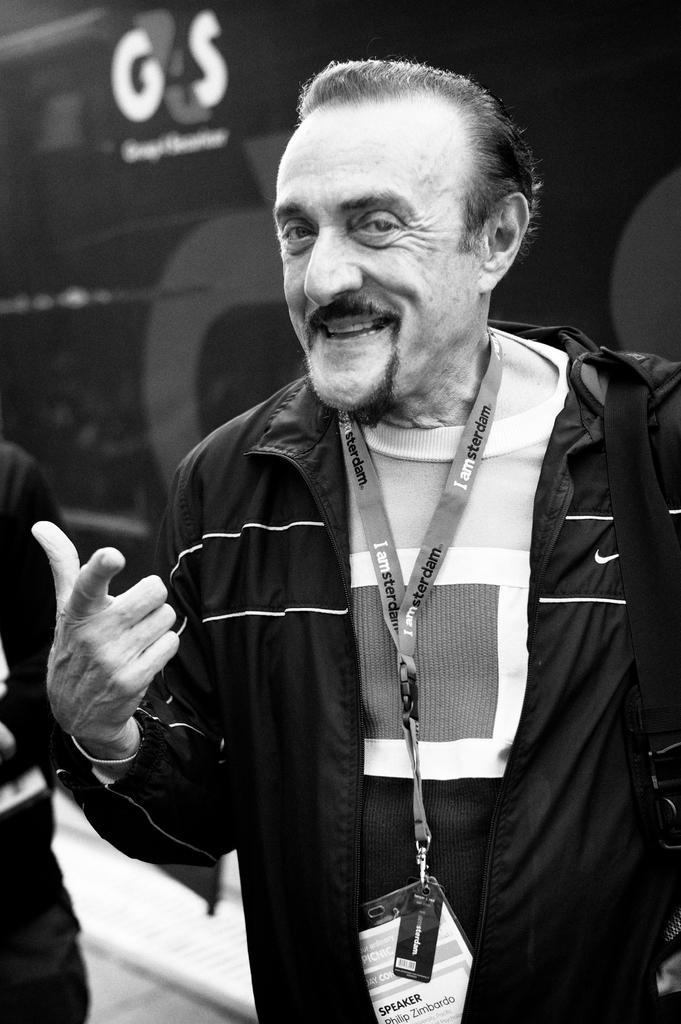How would you summarize this image in a sentence or two? In this image we can see two persons and in the background it looks like a wall with text. 